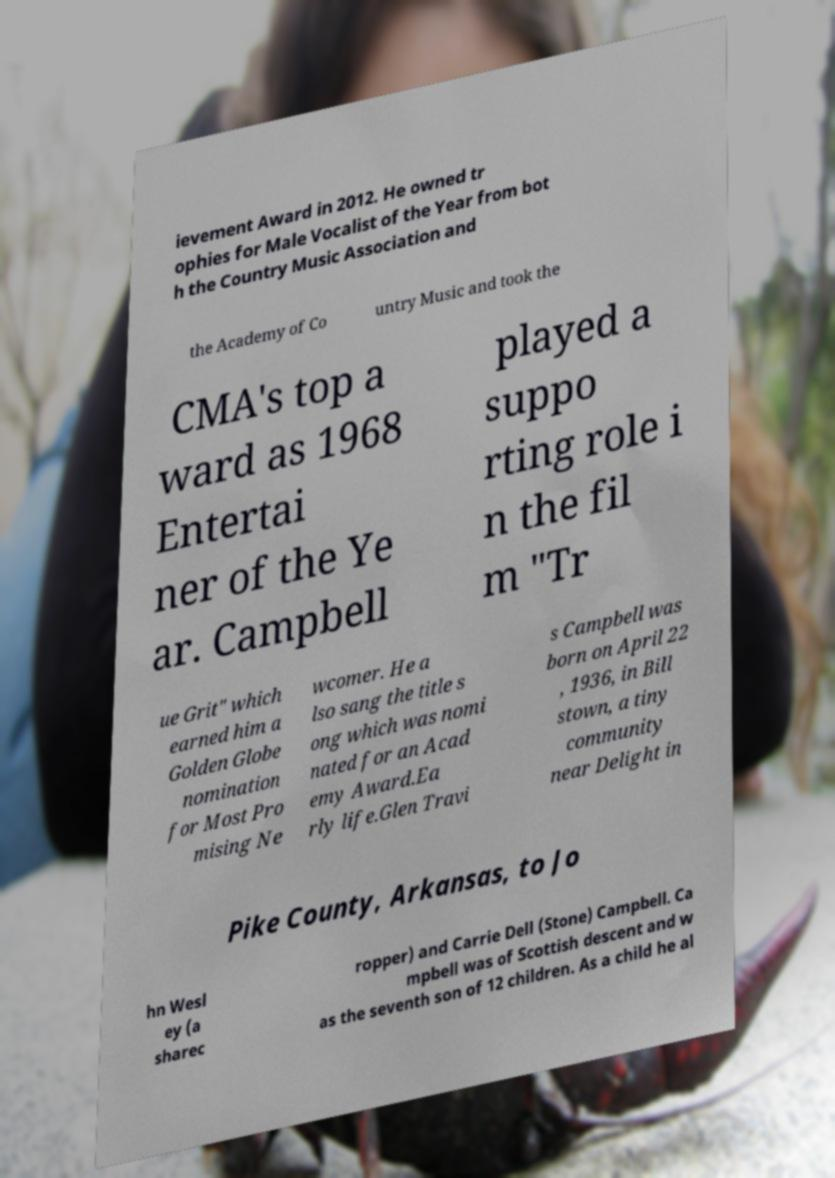I need the written content from this picture converted into text. Can you do that? ievement Award in 2012. He owned tr ophies for Male Vocalist of the Year from bot h the Country Music Association and the Academy of Co untry Music and took the CMA's top a ward as 1968 Entertai ner of the Ye ar. Campbell played a suppo rting role i n the fil m "Tr ue Grit" which earned him a Golden Globe nomination for Most Pro mising Ne wcomer. He a lso sang the title s ong which was nomi nated for an Acad emy Award.Ea rly life.Glen Travi s Campbell was born on April 22 , 1936, in Bill stown, a tiny community near Delight in Pike County, Arkansas, to Jo hn Wesl ey (a sharec ropper) and Carrie Dell (Stone) Campbell. Ca mpbell was of Scottish descent and w as the seventh son of 12 children. As a child he al 